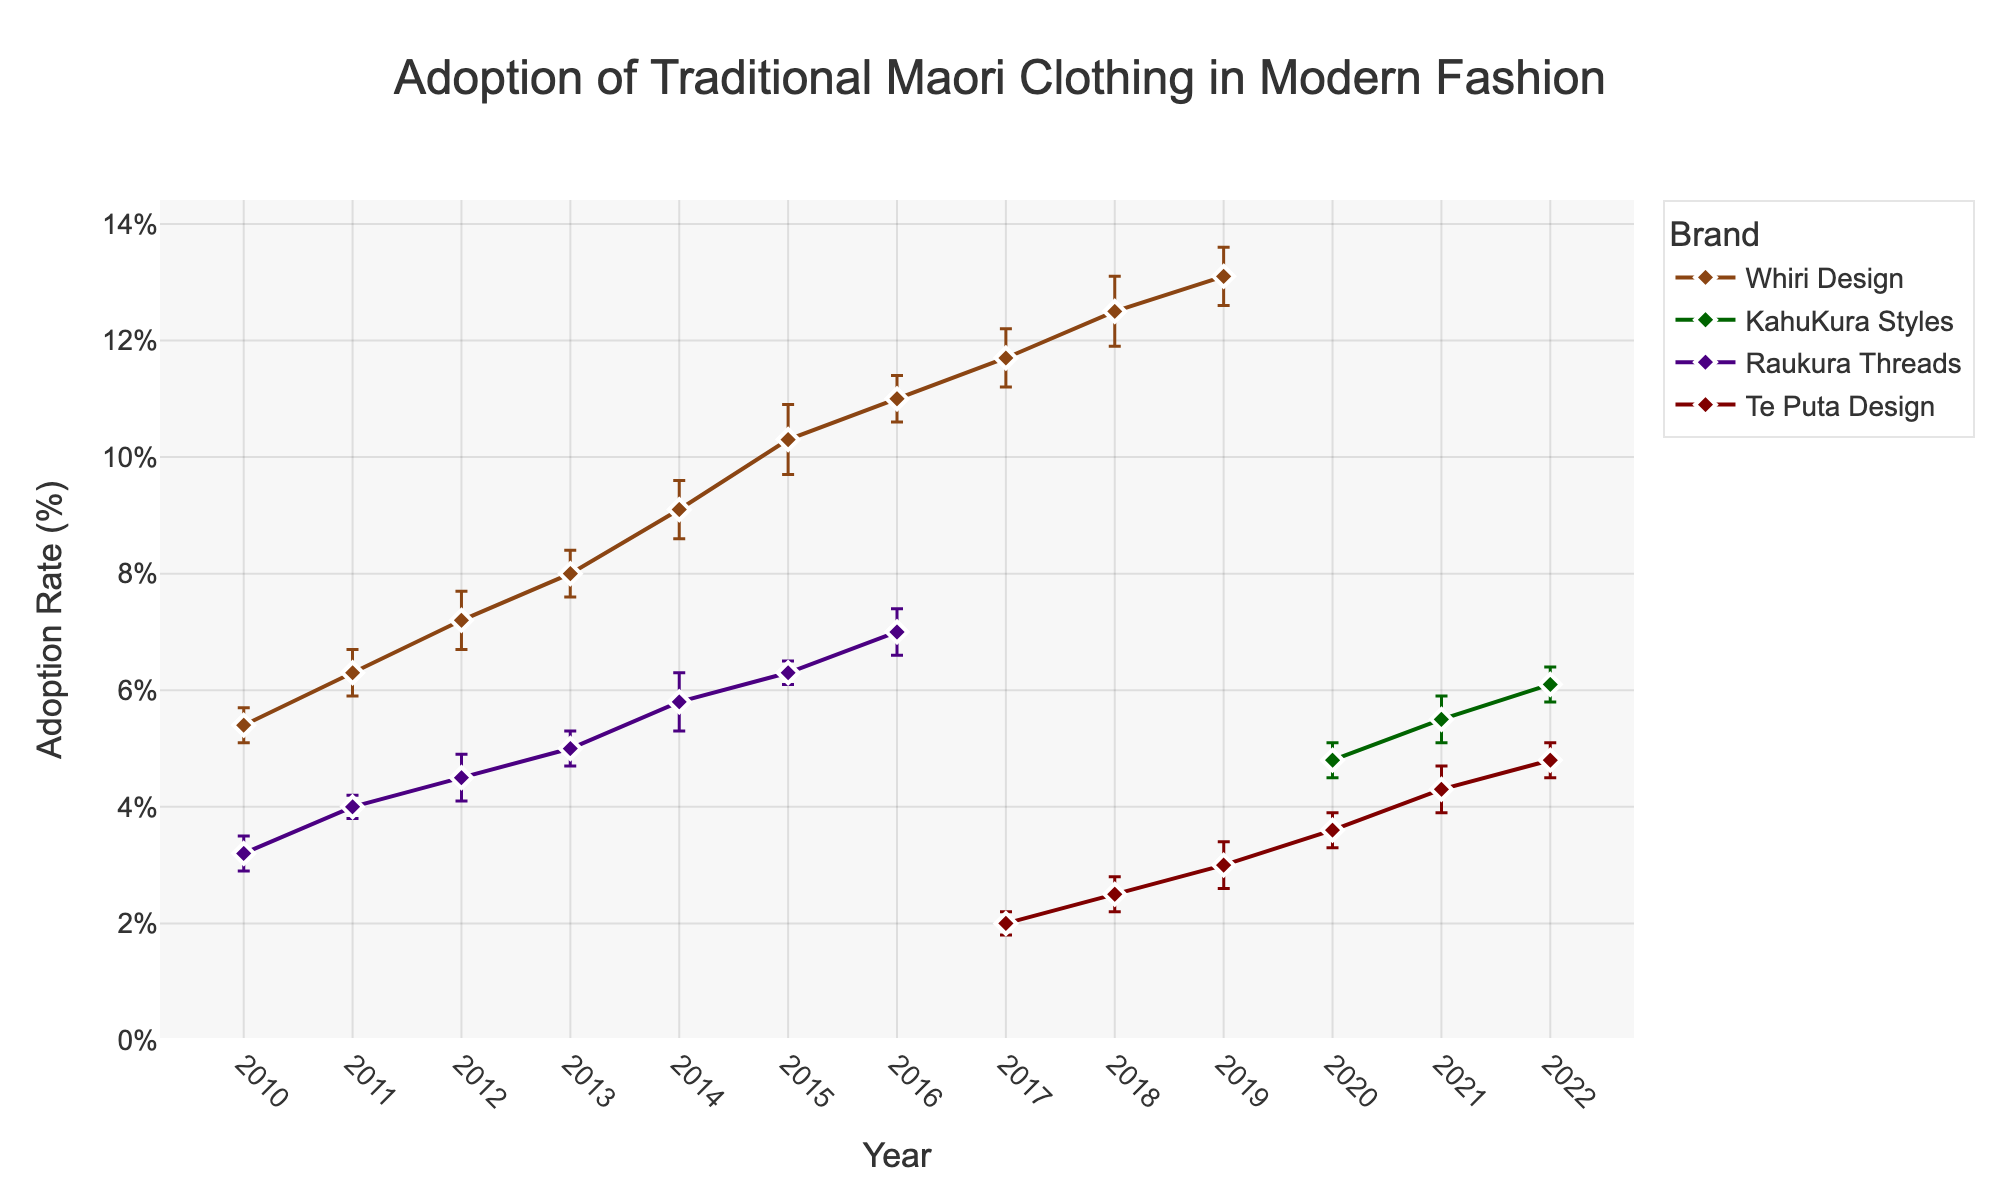What is the title of the plot? The title of the plot is shown at the top center of the figure, indicating the main topic.
Answer: Adoption of Traditional Maori Clothing in Modern Fashion Which axis represents the years in the plot? The horizontal axis (X-axis) displays the years in the figure, ranging from 2010 to 2022.
Answer: X-axis What is the adoption rate of Whiri Design in 2015? By locating the data point for Whiri Design in 2015 on the plot, we see it's marked at 10.3%.
Answer: 10.3% Which brand has the highest adoption rate in 2022? By checking the endpoints of each line at the year 2022, Whiri Design reaches the highest adoption rate.
Answer: Whiri Design How does the error margin in 2020 compare between Whiri Design and KahuKura Styles? In 2020, the error margins of Whiri Design and KahuKura Styles are both observable. Whiri Design has an error margin of 0.5, while KahuKura Styles has 0.3, making Whiri Design's margin larger.
Answer: Whiri Design has a larger error margin What trend do you observe in the adoption rate of Raukura Threads from 2010 to 2016? Observing the markers for Raukura Threads from 2010 to 2016, there's a consistent upward trend shown by an increasing line from 3.2% to 7.0%.
Answer: An increasing trend Which brand shows the smallest error margin across the years, and in which year does it occur? The smallest error margin through the years is for Raukura Threads in 2011 with an error of 0.2.
Answer: Raukura Threads, 2011 What is the average adoption rate of Te Puta Design across the years it has data? Adding the adoption rates of Te Puta Design (2.0, 2.5, 3.0, 3.6, 4.3, 4.8) and dividing by the number of years (6) gives (2.0+2.5+3.0+3.6+4.3+4.8) / 6 = 20.2 / 6 ≈ 3.37.
Answer: 3.37 